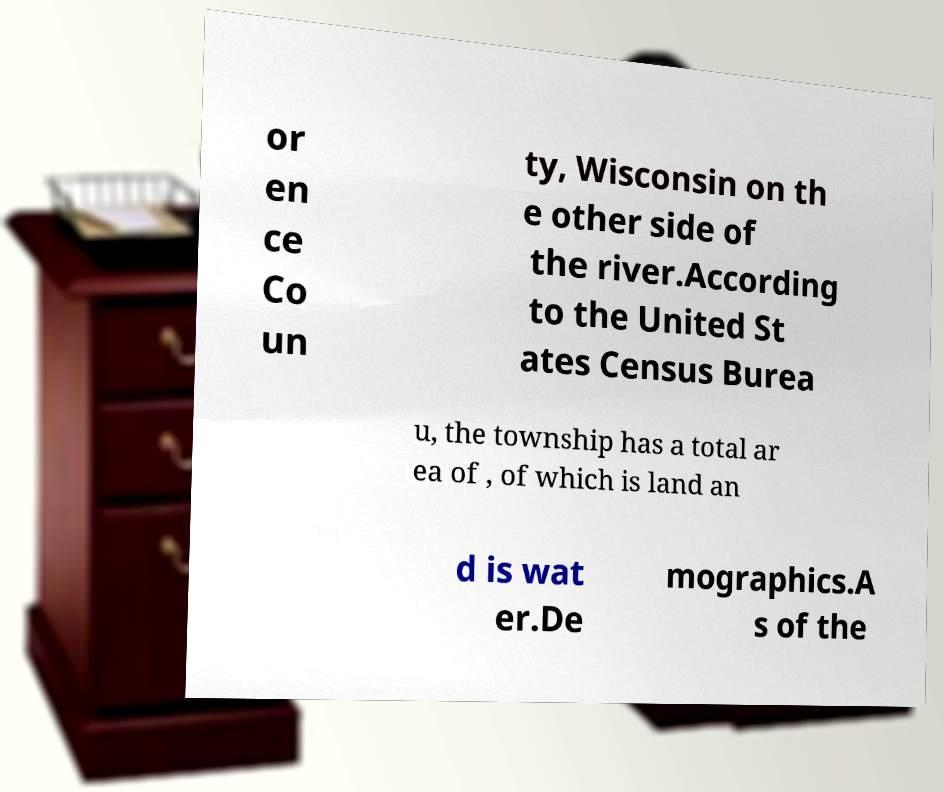Please identify and transcribe the text found in this image. or en ce Co un ty, Wisconsin on th e other side of the river.According to the United St ates Census Burea u, the township has a total ar ea of , of which is land an d is wat er.De mographics.A s of the 